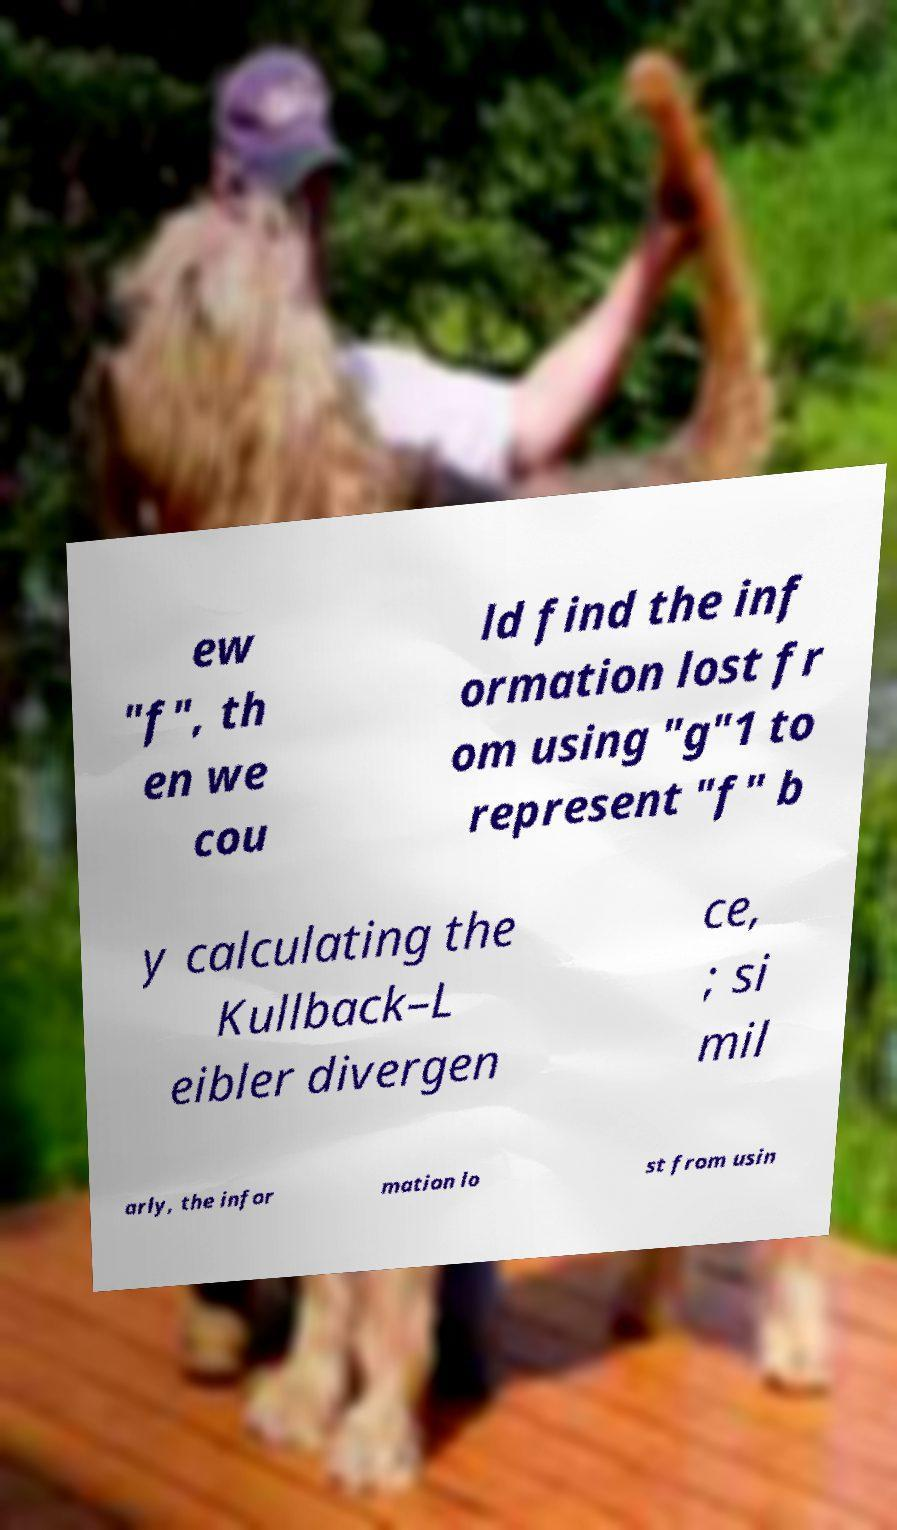Can you accurately transcribe the text from the provided image for me? ew "f", th en we cou ld find the inf ormation lost fr om using "g"1 to represent "f" b y calculating the Kullback–L eibler divergen ce, ; si mil arly, the infor mation lo st from usin 